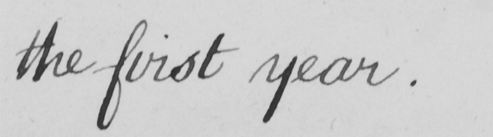What does this handwritten line say? the first year . 